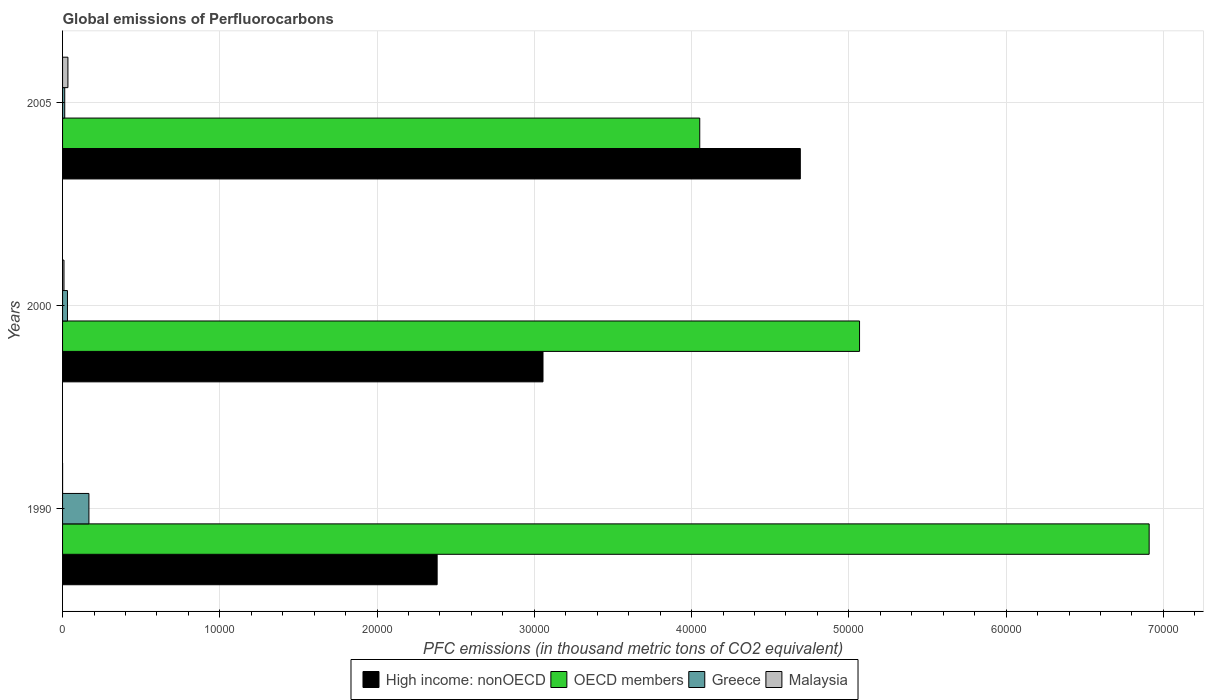How many different coloured bars are there?
Your response must be concise. 4. How many groups of bars are there?
Provide a succinct answer. 3. Are the number of bars per tick equal to the number of legend labels?
Your answer should be compact. Yes. Are the number of bars on each tick of the Y-axis equal?
Keep it short and to the point. Yes. How many bars are there on the 2nd tick from the bottom?
Keep it short and to the point. 4. What is the label of the 2nd group of bars from the top?
Provide a succinct answer. 2000. In how many cases, is the number of bars for a given year not equal to the number of legend labels?
Keep it short and to the point. 0. What is the global emissions of Perfluorocarbons in Malaysia in 2000?
Give a very brief answer. 90.1. Across all years, what is the maximum global emissions of Perfluorocarbons in OECD members?
Offer a terse response. 6.91e+04. In which year was the global emissions of Perfluorocarbons in Malaysia maximum?
Provide a succinct answer. 2005. In which year was the global emissions of Perfluorocarbons in Greece minimum?
Ensure brevity in your answer.  2005. What is the total global emissions of Perfluorocarbons in OECD members in the graph?
Keep it short and to the point. 1.60e+05. What is the difference between the global emissions of Perfluorocarbons in Greece in 1990 and that in 2005?
Your response must be concise. 1538.4. What is the difference between the global emissions of Perfluorocarbons in High income: nonOECD in 2005 and the global emissions of Perfluorocarbons in Greece in 2000?
Provide a short and direct response. 4.66e+04. What is the average global emissions of Perfluorocarbons in Malaysia per year?
Your answer should be compact. 143.87. In the year 1990, what is the difference between the global emissions of Perfluorocarbons in Malaysia and global emissions of Perfluorocarbons in High income: nonOECD?
Provide a short and direct response. -2.38e+04. In how many years, is the global emissions of Perfluorocarbons in OECD members greater than 36000 thousand metric tons?
Your response must be concise. 3. What is the ratio of the global emissions of Perfluorocarbons in High income: nonOECD in 2000 to that in 2005?
Offer a very short reply. 0.65. Is the difference between the global emissions of Perfluorocarbons in Malaysia in 1990 and 2005 greater than the difference between the global emissions of Perfluorocarbons in High income: nonOECD in 1990 and 2005?
Your response must be concise. Yes. What is the difference between the highest and the second highest global emissions of Perfluorocarbons in Greece?
Make the answer very short. 1364.6. What is the difference between the highest and the lowest global emissions of Perfluorocarbons in High income: nonOECD?
Keep it short and to the point. 2.31e+04. Is it the case that in every year, the sum of the global emissions of Perfluorocarbons in Malaysia and global emissions of Perfluorocarbons in High income: nonOECD is greater than the sum of global emissions of Perfluorocarbons in Greece and global emissions of Perfluorocarbons in OECD members?
Offer a very short reply. No. What does the 1st bar from the top in 1990 represents?
Keep it short and to the point. Malaysia. What does the 3rd bar from the bottom in 2000 represents?
Your response must be concise. Greece. Are all the bars in the graph horizontal?
Offer a terse response. Yes. How many years are there in the graph?
Your answer should be very brief. 3. What is the difference between two consecutive major ticks on the X-axis?
Keep it short and to the point. 10000. Does the graph contain any zero values?
Offer a terse response. No. How many legend labels are there?
Make the answer very short. 4. How are the legend labels stacked?
Ensure brevity in your answer.  Horizontal. What is the title of the graph?
Provide a succinct answer. Global emissions of Perfluorocarbons. Does "New Caledonia" appear as one of the legend labels in the graph?
Give a very brief answer. No. What is the label or title of the X-axis?
Provide a short and direct response. PFC emissions (in thousand metric tons of CO2 equivalent). What is the PFC emissions (in thousand metric tons of CO2 equivalent) of High income: nonOECD in 1990?
Your answer should be very brief. 2.38e+04. What is the PFC emissions (in thousand metric tons of CO2 equivalent) in OECD members in 1990?
Give a very brief answer. 6.91e+04. What is the PFC emissions (in thousand metric tons of CO2 equivalent) of Greece in 1990?
Ensure brevity in your answer.  1675.9. What is the PFC emissions (in thousand metric tons of CO2 equivalent) in High income: nonOECD in 2000?
Offer a terse response. 3.06e+04. What is the PFC emissions (in thousand metric tons of CO2 equivalent) of OECD members in 2000?
Your answer should be very brief. 5.07e+04. What is the PFC emissions (in thousand metric tons of CO2 equivalent) of Greece in 2000?
Provide a succinct answer. 311.3. What is the PFC emissions (in thousand metric tons of CO2 equivalent) in Malaysia in 2000?
Offer a terse response. 90.1. What is the PFC emissions (in thousand metric tons of CO2 equivalent) in High income: nonOECD in 2005?
Offer a very short reply. 4.69e+04. What is the PFC emissions (in thousand metric tons of CO2 equivalent) of OECD members in 2005?
Ensure brevity in your answer.  4.05e+04. What is the PFC emissions (in thousand metric tons of CO2 equivalent) of Greece in 2005?
Ensure brevity in your answer.  137.5. What is the PFC emissions (in thousand metric tons of CO2 equivalent) of Malaysia in 2005?
Your answer should be very brief. 340.9. Across all years, what is the maximum PFC emissions (in thousand metric tons of CO2 equivalent) of High income: nonOECD?
Keep it short and to the point. 4.69e+04. Across all years, what is the maximum PFC emissions (in thousand metric tons of CO2 equivalent) in OECD members?
Offer a terse response. 6.91e+04. Across all years, what is the maximum PFC emissions (in thousand metric tons of CO2 equivalent) in Greece?
Offer a very short reply. 1675.9. Across all years, what is the maximum PFC emissions (in thousand metric tons of CO2 equivalent) in Malaysia?
Offer a terse response. 340.9. Across all years, what is the minimum PFC emissions (in thousand metric tons of CO2 equivalent) of High income: nonOECD?
Your response must be concise. 2.38e+04. Across all years, what is the minimum PFC emissions (in thousand metric tons of CO2 equivalent) in OECD members?
Your answer should be very brief. 4.05e+04. Across all years, what is the minimum PFC emissions (in thousand metric tons of CO2 equivalent) of Greece?
Provide a short and direct response. 137.5. Across all years, what is the minimum PFC emissions (in thousand metric tons of CO2 equivalent) in Malaysia?
Your answer should be very brief. 0.6. What is the total PFC emissions (in thousand metric tons of CO2 equivalent) of High income: nonOECD in the graph?
Your response must be concise. 1.01e+05. What is the total PFC emissions (in thousand metric tons of CO2 equivalent) in OECD members in the graph?
Provide a short and direct response. 1.60e+05. What is the total PFC emissions (in thousand metric tons of CO2 equivalent) of Greece in the graph?
Offer a terse response. 2124.7. What is the total PFC emissions (in thousand metric tons of CO2 equivalent) in Malaysia in the graph?
Keep it short and to the point. 431.6. What is the difference between the PFC emissions (in thousand metric tons of CO2 equivalent) in High income: nonOECD in 1990 and that in 2000?
Give a very brief answer. -6731.3. What is the difference between the PFC emissions (in thousand metric tons of CO2 equivalent) of OECD members in 1990 and that in 2000?
Give a very brief answer. 1.84e+04. What is the difference between the PFC emissions (in thousand metric tons of CO2 equivalent) of Greece in 1990 and that in 2000?
Make the answer very short. 1364.6. What is the difference between the PFC emissions (in thousand metric tons of CO2 equivalent) of Malaysia in 1990 and that in 2000?
Your answer should be very brief. -89.5. What is the difference between the PFC emissions (in thousand metric tons of CO2 equivalent) of High income: nonOECD in 1990 and that in 2005?
Your response must be concise. -2.31e+04. What is the difference between the PFC emissions (in thousand metric tons of CO2 equivalent) in OECD members in 1990 and that in 2005?
Your answer should be compact. 2.86e+04. What is the difference between the PFC emissions (in thousand metric tons of CO2 equivalent) of Greece in 1990 and that in 2005?
Ensure brevity in your answer.  1538.4. What is the difference between the PFC emissions (in thousand metric tons of CO2 equivalent) in Malaysia in 1990 and that in 2005?
Your answer should be very brief. -340.3. What is the difference between the PFC emissions (in thousand metric tons of CO2 equivalent) in High income: nonOECD in 2000 and that in 2005?
Offer a terse response. -1.64e+04. What is the difference between the PFC emissions (in thousand metric tons of CO2 equivalent) in OECD members in 2000 and that in 2005?
Make the answer very short. 1.02e+04. What is the difference between the PFC emissions (in thousand metric tons of CO2 equivalent) of Greece in 2000 and that in 2005?
Provide a short and direct response. 173.8. What is the difference between the PFC emissions (in thousand metric tons of CO2 equivalent) in Malaysia in 2000 and that in 2005?
Your answer should be compact. -250.8. What is the difference between the PFC emissions (in thousand metric tons of CO2 equivalent) of High income: nonOECD in 1990 and the PFC emissions (in thousand metric tons of CO2 equivalent) of OECD members in 2000?
Your response must be concise. -2.69e+04. What is the difference between the PFC emissions (in thousand metric tons of CO2 equivalent) of High income: nonOECD in 1990 and the PFC emissions (in thousand metric tons of CO2 equivalent) of Greece in 2000?
Offer a terse response. 2.35e+04. What is the difference between the PFC emissions (in thousand metric tons of CO2 equivalent) in High income: nonOECD in 1990 and the PFC emissions (in thousand metric tons of CO2 equivalent) in Malaysia in 2000?
Your answer should be compact. 2.37e+04. What is the difference between the PFC emissions (in thousand metric tons of CO2 equivalent) of OECD members in 1990 and the PFC emissions (in thousand metric tons of CO2 equivalent) of Greece in 2000?
Provide a short and direct response. 6.88e+04. What is the difference between the PFC emissions (in thousand metric tons of CO2 equivalent) in OECD members in 1990 and the PFC emissions (in thousand metric tons of CO2 equivalent) in Malaysia in 2000?
Provide a succinct answer. 6.90e+04. What is the difference between the PFC emissions (in thousand metric tons of CO2 equivalent) in Greece in 1990 and the PFC emissions (in thousand metric tons of CO2 equivalent) in Malaysia in 2000?
Your answer should be compact. 1585.8. What is the difference between the PFC emissions (in thousand metric tons of CO2 equivalent) in High income: nonOECD in 1990 and the PFC emissions (in thousand metric tons of CO2 equivalent) in OECD members in 2005?
Your answer should be compact. -1.67e+04. What is the difference between the PFC emissions (in thousand metric tons of CO2 equivalent) of High income: nonOECD in 1990 and the PFC emissions (in thousand metric tons of CO2 equivalent) of Greece in 2005?
Make the answer very short. 2.37e+04. What is the difference between the PFC emissions (in thousand metric tons of CO2 equivalent) of High income: nonOECD in 1990 and the PFC emissions (in thousand metric tons of CO2 equivalent) of Malaysia in 2005?
Your response must be concise. 2.35e+04. What is the difference between the PFC emissions (in thousand metric tons of CO2 equivalent) of OECD members in 1990 and the PFC emissions (in thousand metric tons of CO2 equivalent) of Greece in 2005?
Your answer should be compact. 6.90e+04. What is the difference between the PFC emissions (in thousand metric tons of CO2 equivalent) in OECD members in 1990 and the PFC emissions (in thousand metric tons of CO2 equivalent) in Malaysia in 2005?
Provide a short and direct response. 6.88e+04. What is the difference between the PFC emissions (in thousand metric tons of CO2 equivalent) of Greece in 1990 and the PFC emissions (in thousand metric tons of CO2 equivalent) of Malaysia in 2005?
Keep it short and to the point. 1335. What is the difference between the PFC emissions (in thousand metric tons of CO2 equivalent) of High income: nonOECD in 2000 and the PFC emissions (in thousand metric tons of CO2 equivalent) of OECD members in 2005?
Your answer should be very brief. -9967.92. What is the difference between the PFC emissions (in thousand metric tons of CO2 equivalent) in High income: nonOECD in 2000 and the PFC emissions (in thousand metric tons of CO2 equivalent) in Greece in 2005?
Your answer should be compact. 3.04e+04. What is the difference between the PFC emissions (in thousand metric tons of CO2 equivalent) of High income: nonOECD in 2000 and the PFC emissions (in thousand metric tons of CO2 equivalent) of Malaysia in 2005?
Offer a very short reply. 3.02e+04. What is the difference between the PFC emissions (in thousand metric tons of CO2 equivalent) in OECD members in 2000 and the PFC emissions (in thousand metric tons of CO2 equivalent) in Greece in 2005?
Make the answer very short. 5.05e+04. What is the difference between the PFC emissions (in thousand metric tons of CO2 equivalent) in OECD members in 2000 and the PFC emissions (in thousand metric tons of CO2 equivalent) in Malaysia in 2005?
Offer a very short reply. 5.03e+04. What is the difference between the PFC emissions (in thousand metric tons of CO2 equivalent) in Greece in 2000 and the PFC emissions (in thousand metric tons of CO2 equivalent) in Malaysia in 2005?
Keep it short and to the point. -29.6. What is the average PFC emissions (in thousand metric tons of CO2 equivalent) in High income: nonOECD per year?
Provide a succinct answer. 3.38e+04. What is the average PFC emissions (in thousand metric tons of CO2 equivalent) in OECD members per year?
Offer a very short reply. 5.34e+04. What is the average PFC emissions (in thousand metric tons of CO2 equivalent) of Greece per year?
Offer a terse response. 708.23. What is the average PFC emissions (in thousand metric tons of CO2 equivalent) in Malaysia per year?
Your answer should be very brief. 143.87. In the year 1990, what is the difference between the PFC emissions (in thousand metric tons of CO2 equivalent) of High income: nonOECD and PFC emissions (in thousand metric tons of CO2 equivalent) of OECD members?
Keep it short and to the point. -4.53e+04. In the year 1990, what is the difference between the PFC emissions (in thousand metric tons of CO2 equivalent) of High income: nonOECD and PFC emissions (in thousand metric tons of CO2 equivalent) of Greece?
Keep it short and to the point. 2.21e+04. In the year 1990, what is the difference between the PFC emissions (in thousand metric tons of CO2 equivalent) of High income: nonOECD and PFC emissions (in thousand metric tons of CO2 equivalent) of Malaysia?
Provide a short and direct response. 2.38e+04. In the year 1990, what is the difference between the PFC emissions (in thousand metric tons of CO2 equivalent) of OECD members and PFC emissions (in thousand metric tons of CO2 equivalent) of Greece?
Make the answer very short. 6.74e+04. In the year 1990, what is the difference between the PFC emissions (in thousand metric tons of CO2 equivalent) of OECD members and PFC emissions (in thousand metric tons of CO2 equivalent) of Malaysia?
Give a very brief answer. 6.91e+04. In the year 1990, what is the difference between the PFC emissions (in thousand metric tons of CO2 equivalent) in Greece and PFC emissions (in thousand metric tons of CO2 equivalent) in Malaysia?
Provide a short and direct response. 1675.3. In the year 2000, what is the difference between the PFC emissions (in thousand metric tons of CO2 equivalent) in High income: nonOECD and PFC emissions (in thousand metric tons of CO2 equivalent) in OECD members?
Your answer should be compact. -2.01e+04. In the year 2000, what is the difference between the PFC emissions (in thousand metric tons of CO2 equivalent) of High income: nonOECD and PFC emissions (in thousand metric tons of CO2 equivalent) of Greece?
Your answer should be compact. 3.02e+04. In the year 2000, what is the difference between the PFC emissions (in thousand metric tons of CO2 equivalent) in High income: nonOECD and PFC emissions (in thousand metric tons of CO2 equivalent) in Malaysia?
Offer a very short reply. 3.05e+04. In the year 2000, what is the difference between the PFC emissions (in thousand metric tons of CO2 equivalent) in OECD members and PFC emissions (in thousand metric tons of CO2 equivalent) in Greece?
Your answer should be very brief. 5.04e+04. In the year 2000, what is the difference between the PFC emissions (in thousand metric tons of CO2 equivalent) in OECD members and PFC emissions (in thousand metric tons of CO2 equivalent) in Malaysia?
Offer a very short reply. 5.06e+04. In the year 2000, what is the difference between the PFC emissions (in thousand metric tons of CO2 equivalent) of Greece and PFC emissions (in thousand metric tons of CO2 equivalent) of Malaysia?
Make the answer very short. 221.2. In the year 2005, what is the difference between the PFC emissions (in thousand metric tons of CO2 equivalent) in High income: nonOECD and PFC emissions (in thousand metric tons of CO2 equivalent) in OECD members?
Offer a terse response. 6394.7. In the year 2005, what is the difference between the PFC emissions (in thousand metric tons of CO2 equivalent) of High income: nonOECD and PFC emissions (in thousand metric tons of CO2 equivalent) of Greece?
Your response must be concise. 4.68e+04. In the year 2005, what is the difference between the PFC emissions (in thousand metric tons of CO2 equivalent) in High income: nonOECD and PFC emissions (in thousand metric tons of CO2 equivalent) in Malaysia?
Keep it short and to the point. 4.66e+04. In the year 2005, what is the difference between the PFC emissions (in thousand metric tons of CO2 equivalent) of OECD members and PFC emissions (in thousand metric tons of CO2 equivalent) of Greece?
Provide a succinct answer. 4.04e+04. In the year 2005, what is the difference between the PFC emissions (in thousand metric tons of CO2 equivalent) in OECD members and PFC emissions (in thousand metric tons of CO2 equivalent) in Malaysia?
Provide a succinct answer. 4.02e+04. In the year 2005, what is the difference between the PFC emissions (in thousand metric tons of CO2 equivalent) of Greece and PFC emissions (in thousand metric tons of CO2 equivalent) of Malaysia?
Keep it short and to the point. -203.4. What is the ratio of the PFC emissions (in thousand metric tons of CO2 equivalent) of High income: nonOECD in 1990 to that in 2000?
Offer a terse response. 0.78. What is the ratio of the PFC emissions (in thousand metric tons of CO2 equivalent) of OECD members in 1990 to that in 2000?
Your answer should be compact. 1.36. What is the ratio of the PFC emissions (in thousand metric tons of CO2 equivalent) of Greece in 1990 to that in 2000?
Your answer should be compact. 5.38. What is the ratio of the PFC emissions (in thousand metric tons of CO2 equivalent) in Malaysia in 1990 to that in 2000?
Provide a succinct answer. 0.01. What is the ratio of the PFC emissions (in thousand metric tons of CO2 equivalent) in High income: nonOECD in 1990 to that in 2005?
Give a very brief answer. 0.51. What is the ratio of the PFC emissions (in thousand metric tons of CO2 equivalent) in OECD members in 1990 to that in 2005?
Make the answer very short. 1.71. What is the ratio of the PFC emissions (in thousand metric tons of CO2 equivalent) in Greece in 1990 to that in 2005?
Provide a succinct answer. 12.19. What is the ratio of the PFC emissions (in thousand metric tons of CO2 equivalent) of Malaysia in 1990 to that in 2005?
Offer a terse response. 0. What is the ratio of the PFC emissions (in thousand metric tons of CO2 equivalent) in High income: nonOECD in 2000 to that in 2005?
Offer a very short reply. 0.65. What is the ratio of the PFC emissions (in thousand metric tons of CO2 equivalent) in OECD members in 2000 to that in 2005?
Offer a terse response. 1.25. What is the ratio of the PFC emissions (in thousand metric tons of CO2 equivalent) of Greece in 2000 to that in 2005?
Your response must be concise. 2.26. What is the ratio of the PFC emissions (in thousand metric tons of CO2 equivalent) of Malaysia in 2000 to that in 2005?
Your answer should be compact. 0.26. What is the difference between the highest and the second highest PFC emissions (in thousand metric tons of CO2 equivalent) of High income: nonOECD?
Provide a succinct answer. 1.64e+04. What is the difference between the highest and the second highest PFC emissions (in thousand metric tons of CO2 equivalent) in OECD members?
Offer a very short reply. 1.84e+04. What is the difference between the highest and the second highest PFC emissions (in thousand metric tons of CO2 equivalent) in Greece?
Ensure brevity in your answer.  1364.6. What is the difference between the highest and the second highest PFC emissions (in thousand metric tons of CO2 equivalent) in Malaysia?
Keep it short and to the point. 250.8. What is the difference between the highest and the lowest PFC emissions (in thousand metric tons of CO2 equivalent) of High income: nonOECD?
Keep it short and to the point. 2.31e+04. What is the difference between the highest and the lowest PFC emissions (in thousand metric tons of CO2 equivalent) of OECD members?
Offer a terse response. 2.86e+04. What is the difference between the highest and the lowest PFC emissions (in thousand metric tons of CO2 equivalent) of Greece?
Offer a very short reply. 1538.4. What is the difference between the highest and the lowest PFC emissions (in thousand metric tons of CO2 equivalent) in Malaysia?
Ensure brevity in your answer.  340.3. 